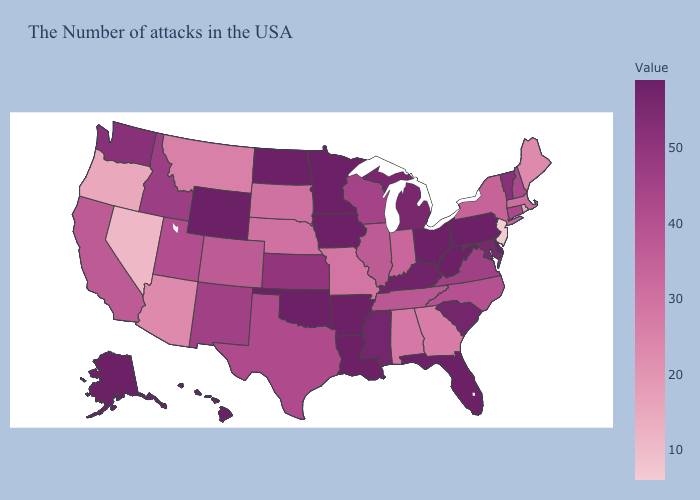Does Colorado have the lowest value in the USA?
Keep it brief. No. Does Maine have a lower value than Nevada?
Be succinct. No. Among the states that border Missouri , does Nebraska have the lowest value?
Write a very short answer. Yes. Does Minnesota have the lowest value in the USA?
Give a very brief answer. No. Does Illinois have a lower value than Michigan?
Write a very short answer. Yes. 